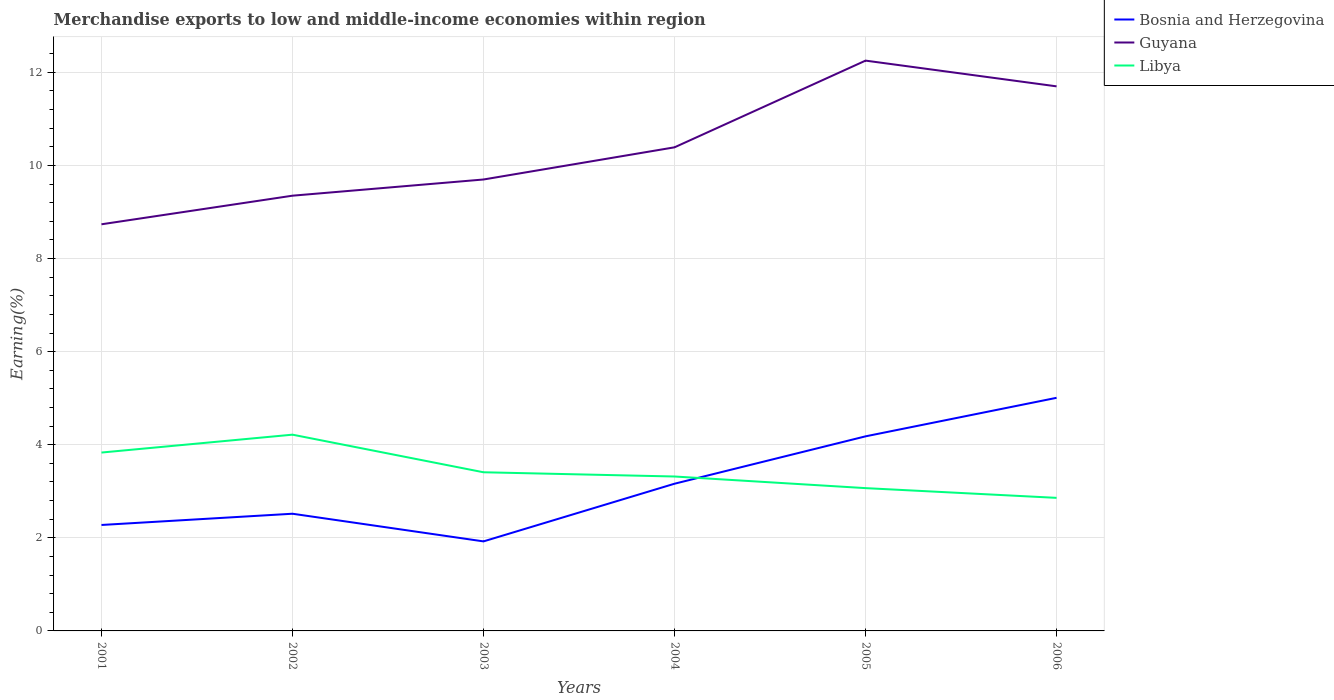How many different coloured lines are there?
Provide a short and direct response. 3. Is the number of lines equal to the number of legend labels?
Give a very brief answer. Yes. Across all years, what is the maximum percentage of amount earned from merchandise exports in Guyana?
Ensure brevity in your answer.  8.74. In which year was the percentage of amount earned from merchandise exports in Bosnia and Herzegovina maximum?
Give a very brief answer. 2003. What is the total percentage of amount earned from merchandise exports in Bosnia and Herzegovina in the graph?
Ensure brevity in your answer.  0.59. What is the difference between the highest and the second highest percentage of amount earned from merchandise exports in Guyana?
Give a very brief answer. 3.52. Is the percentage of amount earned from merchandise exports in Bosnia and Herzegovina strictly greater than the percentage of amount earned from merchandise exports in Guyana over the years?
Your answer should be very brief. Yes. How many lines are there?
Make the answer very short. 3. What is the difference between two consecutive major ticks on the Y-axis?
Provide a succinct answer. 2. Are the values on the major ticks of Y-axis written in scientific E-notation?
Make the answer very short. No. Does the graph contain any zero values?
Your answer should be compact. No. Does the graph contain grids?
Your answer should be very brief. Yes. Where does the legend appear in the graph?
Your answer should be compact. Top right. How are the legend labels stacked?
Offer a terse response. Vertical. What is the title of the graph?
Ensure brevity in your answer.  Merchandise exports to low and middle-income economies within region. What is the label or title of the X-axis?
Offer a very short reply. Years. What is the label or title of the Y-axis?
Offer a very short reply. Earning(%). What is the Earning(%) in Bosnia and Herzegovina in 2001?
Provide a short and direct response. 2.28. What is the Earning(%) of Guyana in 2001?
Give a very brief answer. 8.74. What is the Earning(%) in Libya in 2001?
Provide a short and direct response. 3.83. What is the Earning(%) in Bosnia and Herzegovina in 2002?
Provide a succinct answer. 2.52. What is the Earning(%) in Guyana in 2002?
Provide a short and direct response. 9.35. What is the Earning(%) in Libya in 2002?
Provide a short and direct response. 4.22. What is the Earning(%) in Bosnia and Herzegovina in 2003?
Keep it short and to the point. 1.92. What is the Earning(%) in Guyana in 2003?
Your answer should be very brief. 9.7. What is the Earning(%) of Libya in 2003?
Ensure brevity in your answer.  3.41. What is the Earning(%) in Bosnia and Herzegovina in 2004?
Provide a short and direct response. 3.16. What is the Earning(%) in Guyana in 2004?
Offer a very short reply. 10.39. What is the Earning(%) of Libya in 2004?
Your answer should be compact. 3.32. What is the Earning(%) of Bosnia and Herzegovina in 2005?
Ensure brevity in your answer.  4.18. What is the Earning(%) in Guyana in 2005?
Make the answer very short. 12.25. What is the Earning(%) of Libya in 2005?
Your answer should be compact. 3.07. What is the Earning(%) in Bosnia and Herzegovina in 2006?
Give a very brief answer. 5.01. What is the Earning(%) of Guyana in 2006?
Your response must be concise. 11.7. What is the Earning(%) in Libya in 2006?
Your response must be concise. 2.86. Across all years, what is the maximum Earning(%) in Bosnia and Herzegovina?
Make the answer very short. 5.01. Across all years, what is the maximum Earning(%) in Guyana?
Your response must be concise. 12.25. Across all years, what is the maximum Earning(%) of Libya?
Keep it short and to the point. 4.22. Across all years, what is the minimum Earning(%) in Bosnia and Herzegovina?
Offer a very short reply. 1.92. Across all years, what is the minimum Earning(%) of Guyana?
Provide a short and direct response. 8.74. Across all years, what is the minimum Earning(%) of Libya?
Your answer should be very brief. 2.86. What is the total Earning(%) of Bosnia and Herzegovina in the graph?
Make the answer very short. 19.07. What is the total Earning(%) of Guyana in the graph?
Provide a short and direct response. 62.12. What is the total Earning(%) of Libya in the graph?
Make the answer very short. 20.7. What is the difference between the Earning(%) of Bosnia and Herzegovina in 2001 and that in 2002?
Keep it short and to the point. -0.24. What is the difference between the Earning(%) of Guyana in 2001 and that in 2002?
Your answer should be very brief. -0.61. What is the difference between the Earning(%) in Libya in 2001 and that in 2002?
Offer a very short reply. -0.38. What is the difference between the Earning(%) in Bosnia and Herzegovina in 2001 and that in 2003?
Provide a succinct answer. 0.35. What is the difference between the Earning(%) of Guyana in 2001 and that in 2003?
Give a very brief answer. -0.96. What is the difference between the Earning(%) in Libya in 2001 and that in 2003?
Provide a short and direct response. 0.42. What is the difference between the Earning(%) in Bosnia and Herzegovina in 2001 and that in 2004?
Offer a very short reply. -0.89. What is the difference between the Earning(%) of Guyana in 2001 and that in 2004?
Make the answer very short. -1.65. What is the difference between the Earning(%) in Libya in 2001 and that in 2004?
Offer a terse response. 0.51. What is the difference between the Earning(%) in Bosnia and Herzegovina in 2001 and that in 2005?
Your answer should be very brief. -1.9. What is the difference between the Earning(%) in Guyana in 2001 and that in 2005?
Offer a terse response. -3.52. What is the difference between the Earning(%) in Libya in 2001 and that in 2005?
Provide a short and direct response. 0.76. What is the difference between the Earning(%) of Bosnia and Herzegovina in 2001 and that in 2006?
Offer a terse response. -2.73. What is the difference between the Earning(%) in Guyana in 2001 and that in 2006?
Your response must be concise. -2.96. What is the difference between the Earning(%) of Libya in 2001 and that in 2006?
Offer a terse response. 0.97. What is the difference between the Earning(%) in Bosnia and Herzegovina in 2002 and that in 2003?
Offer a very short reply. 0.59. What is the difference between the Earning(%) of Guyana in 2002 and that in 2003?
Give a very brief answer. -0.35. What is the difference between the Earning(%) of Libya in 2002 and that in 2003?
Give a very brief answer. 0.81. What is the difference between the Earning(%) in Bosnia and Herzegovina in 2002 and that in 2004?
Give a very brief answer. -0.64. What is the difference between the Earning(%) of Guyana in 2002 and that in 2004?
Offer a very short reply. -1.04. What is the difference between the Earning(%) of Libya in 2002 and that in 2004?
Your answer should be compact. 0.9. What is the difference between the Earning(%) of Bosnia and Herzegovina in 2002 and that in 2005?
Your response must be concise. -1.66. What is the difference between the Earning(%) of Guyana in 2002 and that in 2005?
Your answer should be very brief. -2.9. What is the difference between the Earning(%) of Libya in 2002 and that in 2005?
Your answer should be very brief. 1.15. What is the difference between the Earning(%) of Bosnia and Herzegovina in 2002 and that in 2006?
Your answer should be compact. -2.49. What is the difference between the Earning(%) of Guyana in 2002 and that in 2006?
Make the answer very short. -2.35. What is the difference between the Earning(%) of Libya in 2002 and that in 2006?
Your response must be concise. 1.36. What is the difference between the Earning(%) of Bosnia and Herzegovina in 2003 and that in 2004?
Provide a succinct answer. -1.24. What is the difference between the Earning(%) in Guyana in 2003 and that in 2004?
Keep it short and to the point. -0.69. What is the difference between the Earning(%) in Libya in 2003 and that in 2004?
Ensure brevity in your answer.  0.09. What is the difference between the Earning(%) in Bosnia and Herzegovina in 2003 and that in 2005?
Provide a succinct answer. -2.26. What is the difference between the Earning(%) of Guyana in 2003 and that in 2005?
Make the answer very short. -2.55. What is the difference between the Earning(%) in Libya in 2003 and that in 2005?
Offer a terse response. 0.34. What is the difference between the Earning(%) in Bosnia and Herzegovina in 2003 and that in 2006?
Keep it short and to the point. -3.08. What is the difference between the Earning(%) of Guyana in 2003 and that in 2006?
Give a very brief answer. -2. What is the difference between the Earning(%) of Libya in 2003 and that in 2006?
Make the answer very short. 0.55. What is the difference between the Earning(%) in Bosnia and Herzegovina in 2004 and that in 2005?
Offer a terse response. -1.02. What is the difference between the Earning(%) of Guyana in 2004 and that in 2005?
Ensure brevity in your answer.  -1.86. What is the difference between the Earning(%) of Libya in 2004 and that in 2005?
Give a very brief answer. 0.25. What is the difference between the Earning(%) of Bosnia and Herzegovina in 2004 and that in 2006?
Make the answer very short. -1.85. What is the difference between the Earning(%) of Guyana in 2004 and that in 2006?
Offer a terse response. -1.31. What is the difference between the Earning(%) in Libya in 2004 and that in 2006?
Keep it short and to the point. 0.46. What is the difference between the Earning(%) of Bosnia and Herzegovina in 2005 and that in 2006?
Ensure brevity in your answer.  -0.83. What is the difference between the Earning(%) of Guyana in 2005 and that in 2006?
Your answer should be compact. 0.55. What is the difference between the Earning(%) in Libya in 2005 and that in 2006?
Give a very brief answer. 0.21. What is the difference between the Earning(%) in Bosnia and Herzegovina in 2001 and the Earning(%) in Guyana in 2002?
Keep it short and to the point. -7.07. What is the difference between the Earning(%) in Bosnia and Herzegovina in 2001 and the Earning(%) in Libya in 2002?
Provide a short and direct response. -1.94. What is the difference between the Earning(%) of Guyana in 2001 and the Earning(%) of Libya in 2002?
Give a very brief answer. 4.52. What is the difference between the Earning(%) of Bosnia and Herzegovina in 2001 and the Earning(%) of Guyana in 2003?
Your response must be concise. -7.42. What is the difference between the Earning(%) of Bosnia and Herzegovina in 2001 and the Earning(%) of Libya in 2003?
Give a very brief answer. -1.13. What is the difference between the Earning(%) of Guyana in 2001 and the Earning(%) of Libya in 2003?
Provide a succinct answer. 5.33. What is the difference between the Earning(%) in Bosnia and Herzegovina in 2001 and the Earning(%) in Guyana in 2004?
Give a very brief answer. -8.11. What is the difference between the Earning(%) of Bosnia and Herzegovina in 2001 and the Earning(%) of Libya in 2004?
Your answer should be very brief. -1.04. What is the difference between the Earning(%) in Guyana in 2001 and the Earning(%) in Libya in 2004?
Keep it short and to the point. 5.42. What is the difference between the Earning(%) of Bosnia and Herzegovina in 2001 and the Earning(%) of Guyana in 2005?
Provide a short and direct response. -9.98. What is the difference between the Earning(%) in Bosnia and Herzegovina in 2001 and the Earning(%) in Libya in 2005?
Your answer should be very brief. -0.79. What is the difference between the Earning(%) in Guyana in 2001 and the Earning(%) in Libya in 2005?
Give a very brief answer. 5.67. What is the difference between the Earning(%) of Bosnia and Herzegovina in 2001 and the Earning(%) of Guyana in 2006?
Ensure brevity in your answer.  -9.42. What is the difference between the Earning(%) in Bosnia and Herzegovina in 2001 and the Earning(%) in Libya in 2006?
Ensure brevity in your answer.  -0.58. What is the difference between the Earning(%) in Guyana in 2001 and the Earning(%) in Libya in 2006?
Offer a very short reply. 5.88. What is the difference between the Earning(%) in Bosnia and Herzegovina in 2002 and the Earning(%) in Guyana in 2003?
Give a very brief answer. -7.18. What is the difference between the Earning(%) of Bosnia and Herzegovina in 2002 and the Earning(%) of Libya in 2003?
Provide a short and direct response. -0.89. What is the difference between the Earning(%) of Guyana in 2002 and the Earning(%) of Libya in 2003?
Your answer should be compact. 5.94. What is the difference between the Earning(%) in Bosnia and Herzegovina in 2002 and the Earning(%) in Guyana in 2004?
Provide a succinct answer. -7.87. What is the difference between the Earning(%) in Bosnia and Herzegovina in 2002 and the Earning(%) in Libya in 2004?
Keep it short and to the point. -0.8. What is the difference between the Earning(%) of Guyana in 2002 and the Earning(%) of Libya in 2004?
Offer a terse response. 6.03. What is the difference between the Earning(%) in Bosnia and Herzegovina in 2002 and the Earning(%) in Guyana in 2005?
Keep it short and to the point. -9.73. What is the difference between the Earning(%) in Bosnia and Herzegovina in 2002 and the Earning(%) in Libya in 2005?
Give a very brief answer. -0.55. What is the difference between the Earning(%) in Guyana in 2002 and the Earning(%) in Libya in 2005?
Give a very brief answer. 6.28. What is the difference between the Earning(%) in Bosnia and Herzegovina in 2002 and the Earning(%) in Guyana in 2006?
Provide a short and direct response. -9.18. What is the difference between the Earning(%) of Bosnia and Herzegovina in 2002 and the Earning(%) of Libya in 2006?
Make the answer very short. -0.34. What is the difference between the Earning(%) of Guyana in 2002 and the Earning(%) of Libya in 2006?
Give a very brief answer. 6.49. What is the difference between the Earning(%) in Bosnia and Herzegovina in 2003 and the Earning(%) in Guyana in 2004?
Give a very brief answer. -8.47. What is the difference between the Earning(%) in Bosnia and Herzegovina in 2003 and the Earning(%) in Libya in 2004?
Provide a succinct answer. -1.39. What is the difference between the Earning(%) of Guyana in 2003 and the Earning(%) of Libya in 2004?
Your response must be concise. 6.38. What is the difference between the Earning(%) in Bosnia and Herzegovina in 2003 and the Earning(%) in Guyana in 2005?
Keep it short and to the point. -10.33. What is the difference between the Earning(%) of Bosnia and Herzegovina in 2003 and the Earning(%) of Libya in 2005?
Provide a succinct answer. -1.14. What is the difference between the Earning(%) in Guyana in 2003 and the Earning(%) in Libya in 2005?
Ensure brevity in your answer.  6.63. What is the difference between the Earning(%) of Bosnia and Herzegovina in 2003 and the Earning(%) of Guyana in 2006?
Provide a succinct answer. -9.78. What is the difference between the Earning(%) in Bosnia and Herzegovina in 2003 and the Earning(%) in Libya in 2006?
Give a very brief answer. -0.94. What is the difference between the Earning(%) in Guyana in 2003 and the Earning(%) in Libya in 2006?
Make the answer very short. 6.84. What is the difference between the Earning(%) of Bosnia and Herzegovina in 2004 and the Earning(%) of Guyana in 2005?
Ensure brevity in your answer.  -9.09. What is the difference between the Earning(%) in Bosnia and Herzegovina in 2004 and the Earning(%) in Libya in 2005?
Your response must be concise. 0.09. What is the difference between the Earning(%) in Guyana in 2004 and the Earning(%) in Libya in 2005?
Your answer should be compact. 7.32. What is the difference between the Earning(%) in Bosnia and Herzegovina in 2004 and the Earning(%) in Guyana in 2006?
Make the answer very short. -8.54. What is the difference between the Earning(%) in Bosnia and Herzegovina in 2004 and the Earning(%) in Libya in 2006?
Provide a short and direct response. 0.3. What is the difference between the Earning(%) of Guyana in 2004 and the Earning(%) of Libya in 2006?
Your response must be concise. 7.53. What is the difference between the Earning(%) of Bosnia and Herzegovina in 2005 and the Earning(%) of Guyana in 2006?
Make the answer very short. -7.52. What is the difference between the Earning(%) of Bosnia and Herzegovina in 2005 and the Earning(%) of Libya in 2006?
Your answer should be very brief. 1.32. What is the difference between the Earning(%) in Guyana in 2005 and the Earning(%) in Libya in 2006?
Provide a short and direct response. 9.39. What is the average Earning(%) in Bosnia and Herzegovina per year?
Ensure brevity in your answer.  3.18. What is the average Earning(%) in Guyana per year?
Provide a succinct answer. 10.35. What is the average Earning(%) in Libya per year?
Offer a very short reply. 3.45. In the year 2001, what is the difference between the Earning(%) in Bosnia and Herzegovina and Earning(%) in Guyana?
Provide a short and direct response. -6.46. In the year 2001, what is the difference between the Earning(%) in Bosnia and Herzegovina and Earning(%) in Libya?
Offer a very short reply. -1.56. In the year 2001, what is the difference between the Earning(%) in Guyana and Earning(%) in Libya?
Your answer should be compact. 4.9. In the year 2002, what is the difference between the Earning(%) of Bosnia and Herzegovina and Earning(%) of Guyana?
Your response must be concise. -6.83. In the year 2002, what is the difference between the Earning(%) of Bosnia and Herzegovina and Earning(%) of Libya?
Your answer should be compact. -1.7. In the year 2002, what is the difference between the Earning(%) of Guyana and Earning(%) of Libya?
Offer a terse response. 5.13. In the year 2003, what is the difference between the Earning(%) in Bosnia and Herzegovina and Earning(%) in Guyana?
Keep it short and to the point. -7.77. In the year 2003, what is the difference between the Earning(%) of Bosnia and Herzegovina and Earning(%) of Libya?
Your answer should be compact. -1.48. In the year 2003, what is the difference between the Earning(%) in Guyana and Earning(%) in Libya?
Offer a very short reply. 6.29. In the year 2004, what is the difference between the Earning(%) in Bosnia and Herzegovina and Earning(%) in Guyana?
Your answer should be compact. -7.23. In the year 2004, what is the difference between the Earning(%) of Bosnia and Herzegovina and Earning(%) of Libya?
Keep it short and to the point. -0.16. In the year 2004, what is the difference between the Earning(%) of Guyana and Earning(%) of Libya?
Your response must be concise. 7.07. In the year 2005, what is the difference between the Earning(%) of Bosnia and Herzegovina and Earning(%) of Guyana?
Your answer should be compact. -8.07. In the year 2005, what is the difference between the Earning(%) in Bosnia and Herzegovina and Earning(%) in Libya?
Make the answer very short. 1.11. In the year 2005, what is the difference between the Earning(%) in Guyana and Earning(%) in Libya?
Your answer should be compact. 9.18. In the year 2006, what is the difference between the Earning(%) in Bosnia and Herzegovina and Earning(%) in Guyana?
Ensure brevity in your answer.  -6.69. In the year 2006, what is the difference between the Earning(%) in Bosnia and Herzegovina and Earning(%) in Libya?
Your answer should be compact. 2.15. In the year 2006, what is the difference between the Earning(%) in Guyana and Earning(%) in Libya?
Provide a short and direct response. 8.84. What is the ratio of the Earning(%) in Bosnia and Herzegovina in 2001 to that in 2002?
Keep it short and to the point. 0.9. What is the ratio of the Earning(%) in Guyana in 2001 to that in 2002?
Ensure brevity in your answer.  0.93. What is the ratio of the Earning(%) of Libya in 2001 to that in 2002?
Make the answer very short. 0.91. What is the ratio of the Earning(%) in Bosnia and Herzegovina in 2001 to that in 2003?
Make the answer very short. 1.18. What is the ratio of the Earning(%) of Guyana in 2001 to that in 2003?
Offer a very short reply. 0.9. What is the ratio of the Earning(%) in Libya in 2001 to that in 2003?
Offer a terse response. 1.12. What is the ratio of the Earning(%) of Bosnia and Herzegovina in 2001 to that in 2004?
Your response must be concise. 0.72. What is the ratio of the Earning(%) in Guyana in 2001 to that in 2004?
Make the answer very short. 0.84. What is the ratio of the Earning(%) of Libya in 2001 to that in 2004?
Your answer should be compact. 1.16. What is the ratio of the Earning(%) of Bosnia and Herzegovina in 2001 to that in 2005?
Offer a terse response. 0.54. What is the ratio of the Earning(%) in Guyana in 2001 to that in 2005?
Offer a terse response. 0.71. What is the ratio of the Earning(%) in Libya in 2001 to that in 2005?
Give a very brief answer. 1.25. What is the ratio of the Earning(%) of Bosnia and Herzegovina in 2001 to that in 2006?
Your response must be concise. 0.45. What is the ratio of the Earning(%) of Guyana in 2001 to that in 2006?
Give a very brief answer. 0.75. What is the ratio of the Earning(%) in Libya in 2001 to that in 2006?
Ensure brevity in your answer.  1.34. What is the ratio of the Earning(%) in Bosnia and Herzegovina in 2002 to that in 2003?
Keep it short and to the point. 1.31. What is the ratio of the Earning(%) of Guyana in 2002 to that in 2003?
Your answer should be very brief. 0.96. What is the ratio of the Earning(%) of Libya in 2002 to that in 2003?
Your answer should be compact. 1.24. What is the ratio of the Earning(%) of Bosnia and Herzegovina in 2002 to that in 2004?
Ensure brevity in your answer.  0.8. What is the ratio of the Earning(%) in Guyana in 2002 to that in 2004?
Make the answer very short. 0.9. What is the ratio of the Earning(%) in Libya in 2002 to that in 2004?
Make the answer very short. 1.27. What is the ratio of the Earning(%) in Bosnia and Herzegovina in 2002 to that in 2005?
Provide a succinct answer. 0.6. What is the ratio of the Earning(%) of Guyana in 2002 to that in 2005?
Your answer should be very brief. 0.76. What is the ratio of the Earning(%) of Libya in 2002 to that in 2005?
Make the answer very short. 1.37. What is the ratio of the Earning(%) of Bosnia and Herzegovina in 2002 to that in 2006?
Offer a very short reply. 0.5. What is the ratio of the Earning(%) in Guyana in 2002 to that in 2006?
Keep it short and to the point. 0.8. What is the ratio of the Earning(%) in Libya in 2002 to that in 2006?
Ensure brevity in your answer.  1.47. What is the ratio of the Earning(%) of Bosnia and Herzegovina in 2003 to that in 2004?
Your response must be concise. 0.61. What is the ratio of the Earning(%) in Guyana in 2003 to that in 2004?
Make the answer very short. 0.93. What is the ratio of the Earning(%) of Libya in 2003 to that in 2004?
Keep it short and to the point. 1.03. What is the ratio of the Earning(%) in Bosnia and Herzegovina in 2003 to that in 2005?
Ensure brevity in your answer.  0.46. What is the ratio of the Earning(%) of Guyana in 2003 to that in 2005?
Provide a succinct answer. 0.79. What is the ratio of the Earning(%) of Libya in 2003 to that in 2005?
Provide a short and direct response. 1.11. What is the ratio of the Earning(%) in Bosnia and Herzegovina in 2003 to that in 2006?
Your answer should be very brief. 0.38. What is the ratio of the Earning(%) of Guyana in 2003 to that in 2006?
Ensure brevity in your answer.  0.83. What is the ratio of the Earning(%) of Libya in 2003 to that in 2006?
Provide a succinct answer. 1.19. What is the ratio of the Earning(%) of Bosnia and Herzegovina in 2004 to that in 2005?
Keep it short and to the point. 0.76. What is the ratio of the Earning(%) of Guyana in 2004 to that in 2005?
Give a very brief answer. 0.85. What is the ratio of the Earning(%) in Libya in 2004 to that in 2005?
Your answer should be very brief. 1.08. What is the ratio of the Earning(%) in Bosnia and Herzegovina in 2004 to that in 2006?
Provide a succinct answer. 0.63. What is the ratio of the Earning(%) in Guyana in 2004 to that in 2006?
Provide a short and direct response. 0.89. What is the ratio of the Earning(%) in Libya in 2004 to that in 2006?
Provide a succinct answer. 1.16. What is the ratio of the Earning(%) in Bosnia and Herzegovina in 2005 to that in 2006?
Your answer should be compact. 0.83. What is the ratio of the Earning(%) of Guyana in 2005 to that in 2006?
Offer a terse response. 1.05. What is the ratio of the Earning(%) of Libya in 2005 to that in 2006?
Keep it short and to the point. 1.07. What is the difference between the highest and the second highest Earning(%) in Bosnia and Herzegovina?
Provide a short and direct response. 0.83. What is the difference between the highest and the second highest Earning(%) in Guyana?
Your answer should be compact. 0.55. What is the difference between the highest and the second highest Earning(%) of Libya?
Your response must be concise. 0.38. What is the difference between the highest and the lowest Earning(%) in Bosnia and Herzegovina?
Provide a succinct answer. 3.08. What is the difference between the highest and the lowest Earning(%) of Guyana?
Your answer should be compact. 3.52. What is the difference between the highest and the lowest Earning(%) in Libya?
Provide a short and direct response. 1.36. 